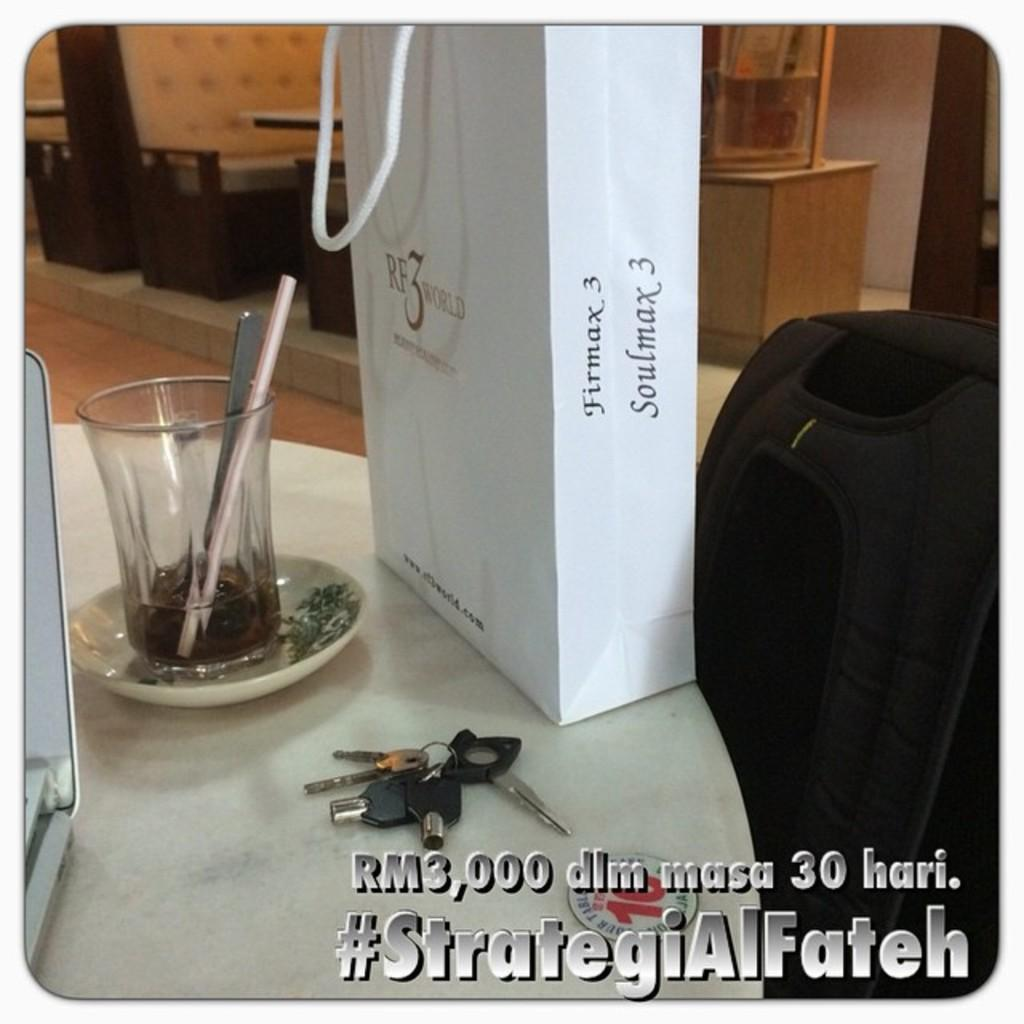<image>
Create a compact narrative representing the image presented. A white giftbag from RF3World on a table next to some keys and a drinking glass. 